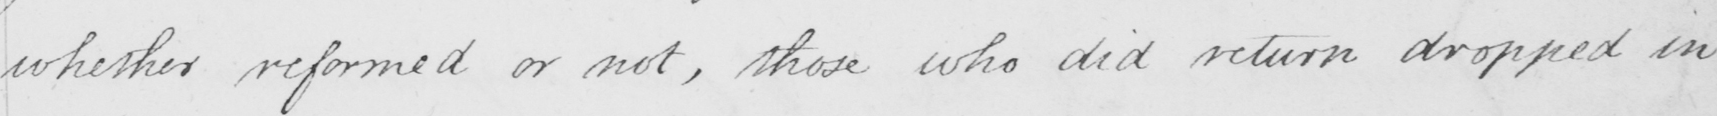Please provide the text content of this handwritten line. whether reformed or not , those who did return dropped in 